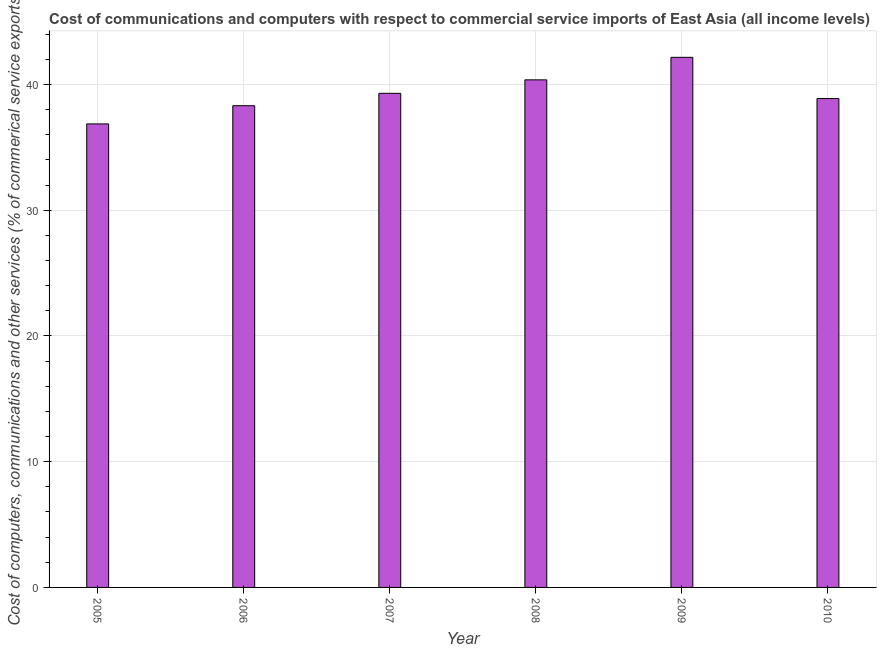Does the graph contain any zero values?
Your answer should be compact. No. Does the graph contain grids?
Keep it short and to the point. Yes. What is the title of the graph?
Offer a very short reply. Cost of communications and computers with respect to commercial service imports of East Asia (all income levels). What is the label or title of the X-axis?
Your answer should be compact. Year. What is the label or title of the Y-axis?
Provide a succinct answer. Cost of computers, communications and other services (% of commerical service exports). What is the  computer and other services in 2008?
Your answer should be very brief. 40.37. Across all years, what is the maximum  computer and other services?
Offer a terse response. 42.16. Across all years, what is the minimum cost of communications?
Ensure brevity in your answer.  36.87. In which year was the cost of communications maximum?
Ensure brevity in your answer.  2009. In which year was the  computer and other services minimum?
Offer a terse response. 2005. What is the sum of the  computer and other services?
Provide a short and direct response. 235.91. What is the difference between the  computer and other services in 2008 and 2010?
Offer a terse response. 1.49. What is the average cost of communications per year?
Your answer should be compact. 39.32. What is the median  computer and other services?
Your answer should be very brief. 39.09. In how many years, is the  computer and other services greater than 26 %?
Offer a very short reply. 6. Do a majority of the years between 2006 and 2010 (inclusive) have cost of communications greater than 22 %?
Your response must be concise. Yes. What is the ratio of the cost of communications in 2006 to that in 2007?
Provide a succinct answer. 0.97. What is the difference between the highest and the second highest  computer and other services?
Your response must be concise. 1.79. Is the sum of the  computer and other services in 2007 and 2009 greater than the maximum  computer and other services across all years?
Your answer should be compact. Yes. What is the difference between the highest and the lowest cost of communications?
Offer a very short reply. 5.3. In how many years, is the  computer and other services greater than the average  computer and other services taken over all years?
Provide a short and direct response. 2. How many bars are there?
Ensure brevity in your answer.  6. How many years are there in the graph?
Ensure brevity in your answer.  6. What is the difference between two consecutive major ticks on the Y-axis?
Offer a terse response. 10. What is the Cost of computers, communications and other services (% of commerical service exports) in 2005?
Your response must be concise. 36.87. What is the Cost of computers, communications and other services (% of commerical service exports) of 2006?
Your answer should be compact. 38.32. What is the Cost of computers, communications and other services (% of commerical service exports) in 2007?
Provide a succinct answer. 39.3. What is the Cost of computers, communications and other services (% of commerical service exports) of 2008?
Ensure brevity in your answer.  40.37. What is the Cost of computers, communications and other services (% of commerical service exports) of 2009?
Your answer should be compact. 42.16. What is the Cost of computers, communications and other services (% of commerical service exports) in 2010?
Your response must be concise. 38.89. What is the difference between the Cost of computers, communications and other services (% of commerical service exports) in 2005 and 2006?
Give a very brief answer. -1.45. What is the difference between the Cost of computers, communications and other services (% of commerical service exports) in 2005 and 2007?
Your answer should be very brief. -2.43. What is the difference between the Cost of computers, communications and other services (% of commerical service exports) in 2005 and 2008?
Make the answer very short. -3.51. What is the difference between the Cost of computers, communications and other services (% of commerical service exports) in 2005 and 2009?
Keep it short and to the point. -5.3. What is the difference between the Cost of computers, communications and other services (% of commerical service exports) in 2005 and 2010?
Offer a very short reply. -2.02. What is the difference between the Cost of computers, communications and other services (% of commerical service exports) in 2006 and 2007?
Make the answer very short. -0.99. What is the difference between the Cost of computers, communications and other services (% of commerical service exports) in 2006 and 2008?
Provide a succinct answer. -2.06. What is the difference between the Cost of computers, communications and other services (% of commerical service exports) in 2006 and 2009?
Provide a short and direct response. -3.85. What is the difference between the Cost of computers, communications and other services (% of commerical service exports) in 2006 and 2010?
Your answer should be very brief. -0.57. What is the difference between the Cost of computers, communications and other services (% of commerical service exports) in 2007 and 2008?
Give a very brief answer. -1.07. What is the difference between the Cost of computers, communications and other services (% of commerical service exports) in 2007 and 2009?
Offer a very short reply. -2.86. What is the difference between the Cost of computers, communications and other services (% of commerical service exports) in 2007 and 2010?
Make the answer very short. 0.42. What is the difference between the Cost of computers, communications and other services (% of commerical service exports) in 2008 and 2009?
Ensure brevity in your answer.  -1.79. What is the difference between the Cost of computers, communications and other services (% of commerical service exports) in 2008 and 2010?
Give a very brief answer. 1.49. What is the difference between the Cost of computers, communications and other services (% of commerical service exports) in 2009 and 2010?
Give a very brief answer. 3.28. What is the ratio of the Cost of computers, communications and other services (% of commerical service exports) in 2005 to that in 2006?
Ensure brevity in your answer.  0.96. What is the ratio of the Cost of computers, communications and other services (% of commerical service exports) in 2005 to that in 2007?
Offer a terse response. 0.94. What is the ratio of the Cost of computers, communications and other services (% of commerical service exports) in 2005 to that in 2008?
Your answer should be very brief. 0.91. What is the ratio of the Cost of computers, communications and other services (% of commerical service exports) in 2005 to that in 2009?
Provide a succinct answer. 0.87. What is the ratio of the Cost of computers, communications and other services (% of commerical service exports) in 2005 to that in 2010?
Offer a terse response. 0.95. What is the ratio of the Cost of computers, communications and other services (% of commerical service exports) in 2006 to that in 2007?
Provide a short and direct response. 0.97. What is the ratio of the Cost of computers, communications and other services (% of commerical service exports) in 2006 to that in 2008?
Offer a terse response. 0.95. What is the ratio of the Cost of computers, communications and other services (% of commerical service exports) in 2006 to that in 2009?
Your response must be concise. 0.91. What is the ratio of the Cost of computers, communications and other services (% of commerical service exports) in 2006 to that in 2010?
Keep it short and to the point. 0.98. What is the ratio of the Cost of computers, communications and other services (% of commerical service exports) in 2007 to that in 2008?
Your response must be concise. 0.97. What is the ratio of the Cost of computers, communications and other services (% of commerical service exports) in 2007 to that in 2009?
Your answer should be very brief. 0.93. What is the ratio of the Cost of computers, communications and other services (% of commerical service exports) in 2008 to that in 2009?
Provide a short and direct response. 0.96. What is the ratio of the Cost of computers, communications and other services (% of commerical service exports) in 2008 to that in 2010?
Keep it short and to the point. 1.04. What is the ratio of the Cost of computers, communications and other services (% of commerical service exports) in 2009 to that in 2010?
Keep it short and to the point. 1.08. 